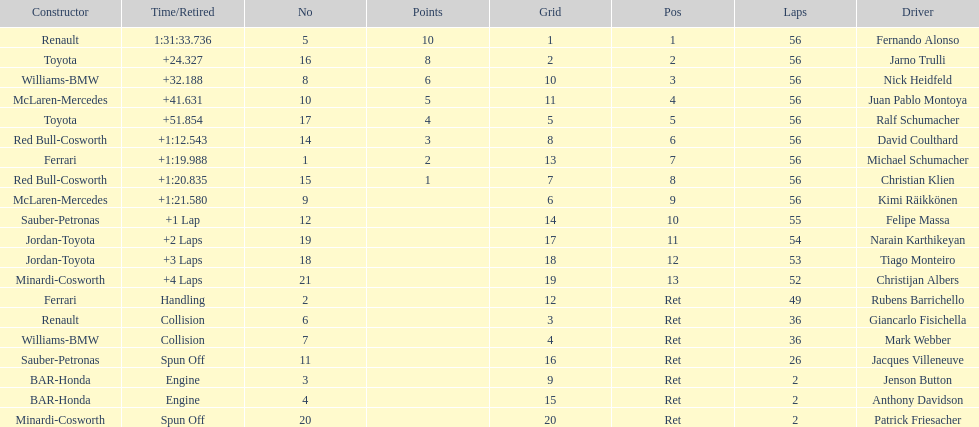How many drivers ended the race early because of engine problems? 2. 